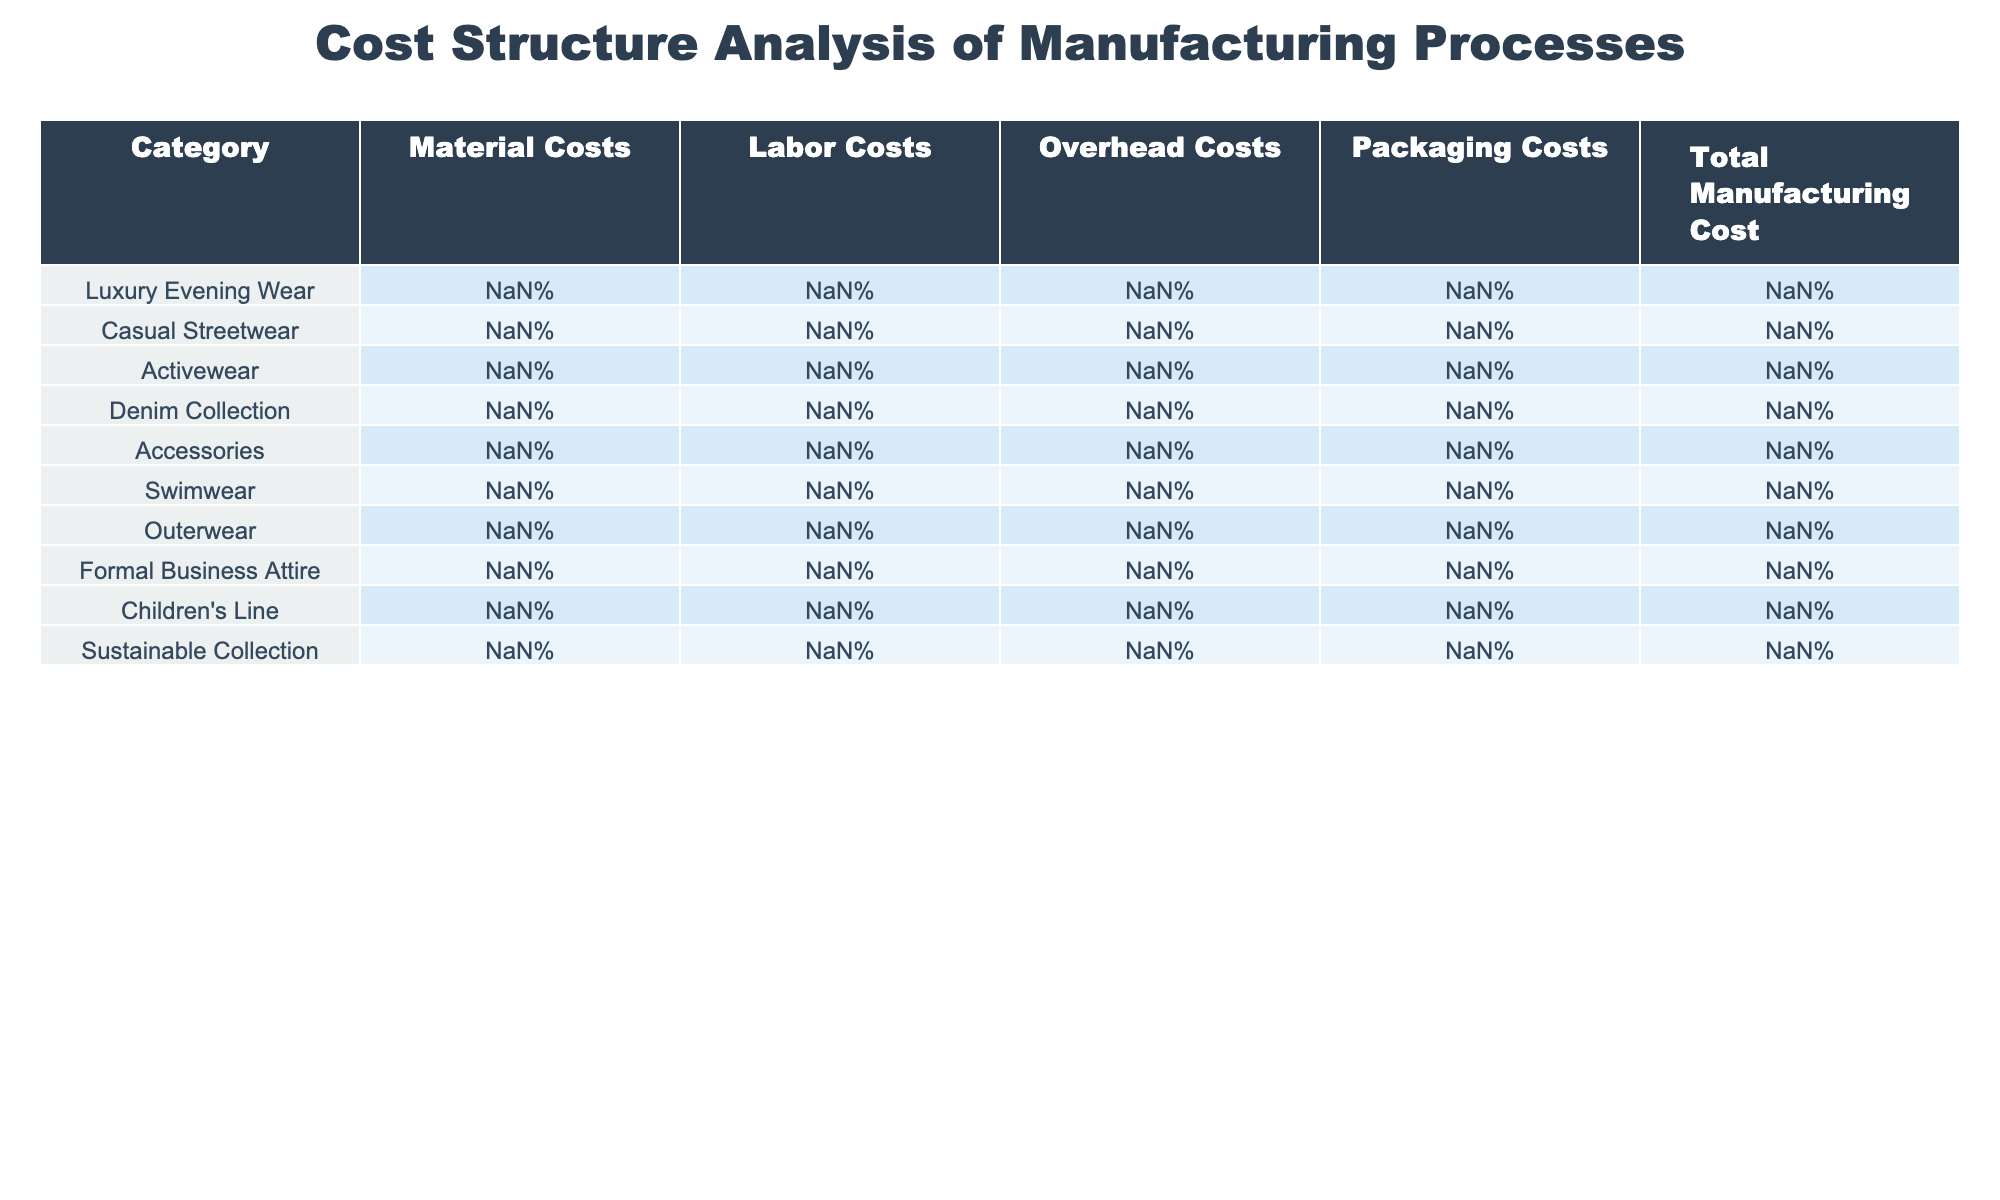What is the material cost percentage for Casual Streetwear? The table indicates that the Material Costs for Casual Streetwear is listed as 38.7%.
Answer: 38.7% Which clothing line has the highest overhead cost percentage? By comparing the overhead cost percentages across all clothing lines, Denim Collection has the highest overhead cost at 26.3%.
Answer: Denim Collection What is the total manufacturing cost percentage of the Luxury Evening Wear? The total manufacturing cost for Luxury Evening Wear is explicitly stated as 100%.
Answer: 100% Calculate the average labor cost percentage for Activewear and Children's Line. The Labor Costs for Activewear is 20.9% and for Children's Line is 26.5%. Adding them gives 20.9% + 26.5% = 47.4%. Dividing by 2 yields the average: 47.4% / 2 = 23.7%.
Answer: 23.7% Is the Packaging Cost percentage for Accessories greater than that for Swimwear? The Packaging Costs for Accessories is 12.3% and for Swimwear is 11.4%. Since 12.3% is greater than 11.4%, the statement is true.
Answer: Yes Which clothing line has the lowest overall labor costs? By evaluating all the labor cost percentages, Activewear with 20.9% has the lowest labor cost.
Answer: Activewear If we sum up the packaging costs for all clothing lines, what percentage do we get? The Packaging Costs are 13.5% (Luxury Evening Wear) + 11.9% (Casual Streetwear) + 11.3% (Activewear) + 11.6% (Denim Collection) + 12.3% (Accessories) + 11.4% (Swimwear) + 12.5% (Outerwear) + 11.6% (Formal Business Attire) + 11.8% (Children's Line) + 10.4% (Sustainable Collection). This totals to 128.2%.
Answer: 128.2% How does the Material Cost percentage of Sustainable Collection compare to that of Outerwear? The Material Cost for Sustainable Collection is 49.6%, while for Outerwear it is 47.3%. Since 49.6% is greater than 47.3%, Sustainable Collection has a higher material cost percentage.
Answer: Higher What is the difference in overhead costs between the Denim Collection and the Accessories? The Overhead Costs for Denim Collection is 22.9% and for Accessories is 23.7%. The difference is 23.7% - 22.9% = 0.8%.
Answer: 0.8% Does the Casual Streetwear have a higher proportion of labor costs compared to the Denim Collection? Casual Streetwear has 25.3% labor costs, while Denim Collection has 21.7%. Thus, 25.3% is greater than 21.7%, making this statement true.
Answer: Yes 